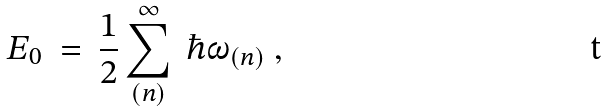Convert formula to latex. <formula><loc_0><loc_0><loc_500><loc_500>E _ { 0 } \ = \ \frac { 1 } { 2 } \sum _ { ( n ) } ^ { \infty } \ \hbar { \omega } _ { ( n ) } \ ,</formula> 